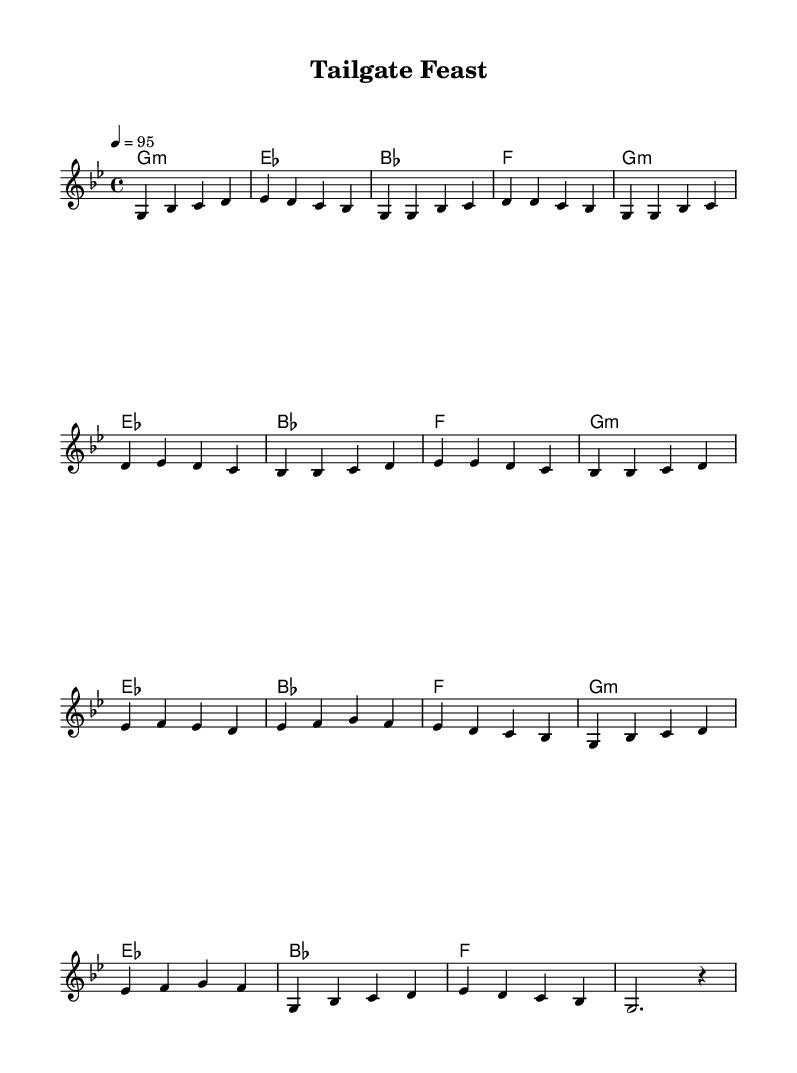What is the key signature of this music? The key signature is indicated by the position of the notes on the staff. Here, the notes include B-flat, which shows that the key is B-flat major or G minor. Since the melody starts on G and follows a minor scale, the key signature is G minor.
Answer: G minor What is the time signature of this music? The time signature is found at the beginning of the score, represented as the fraction 4/4, which indicates that there are four beats in each measure and the quarter note gets one beat.
Answer: 4/4 What is the tempo marking of this music? The tempo marking appears above the staff and indicates how fast the music should be played. It states "4 = 95," which means that there should be 95 beats per minute.
Answer: 95 How many measures are in the verse section? By analyzing the verse section, the measures can be counted. The verse consists of two lines of music, each having four measures, making a total of eight measures in the verse.
Answer: 8 How many chords are used in the harmonies? The harmonies section displays a progression through four distinct chords repeated across the measures. Counting the unique chord changes reveals that there are four different chords used throughout the piece.
Answer: 4 What type of music does this score represent? The music's title, tempo, and style of notation indicate it is composed with elements typical to Hip Hop, particularly with references to street food culture. The rhythms and structure mimic Hip Hop aesthetics.
Answer: Hip Hop What is the last note of the melody? Looking at the final part of the melody, the last note of the score is a G, which is the note that concludes the piece.
Answer: G 